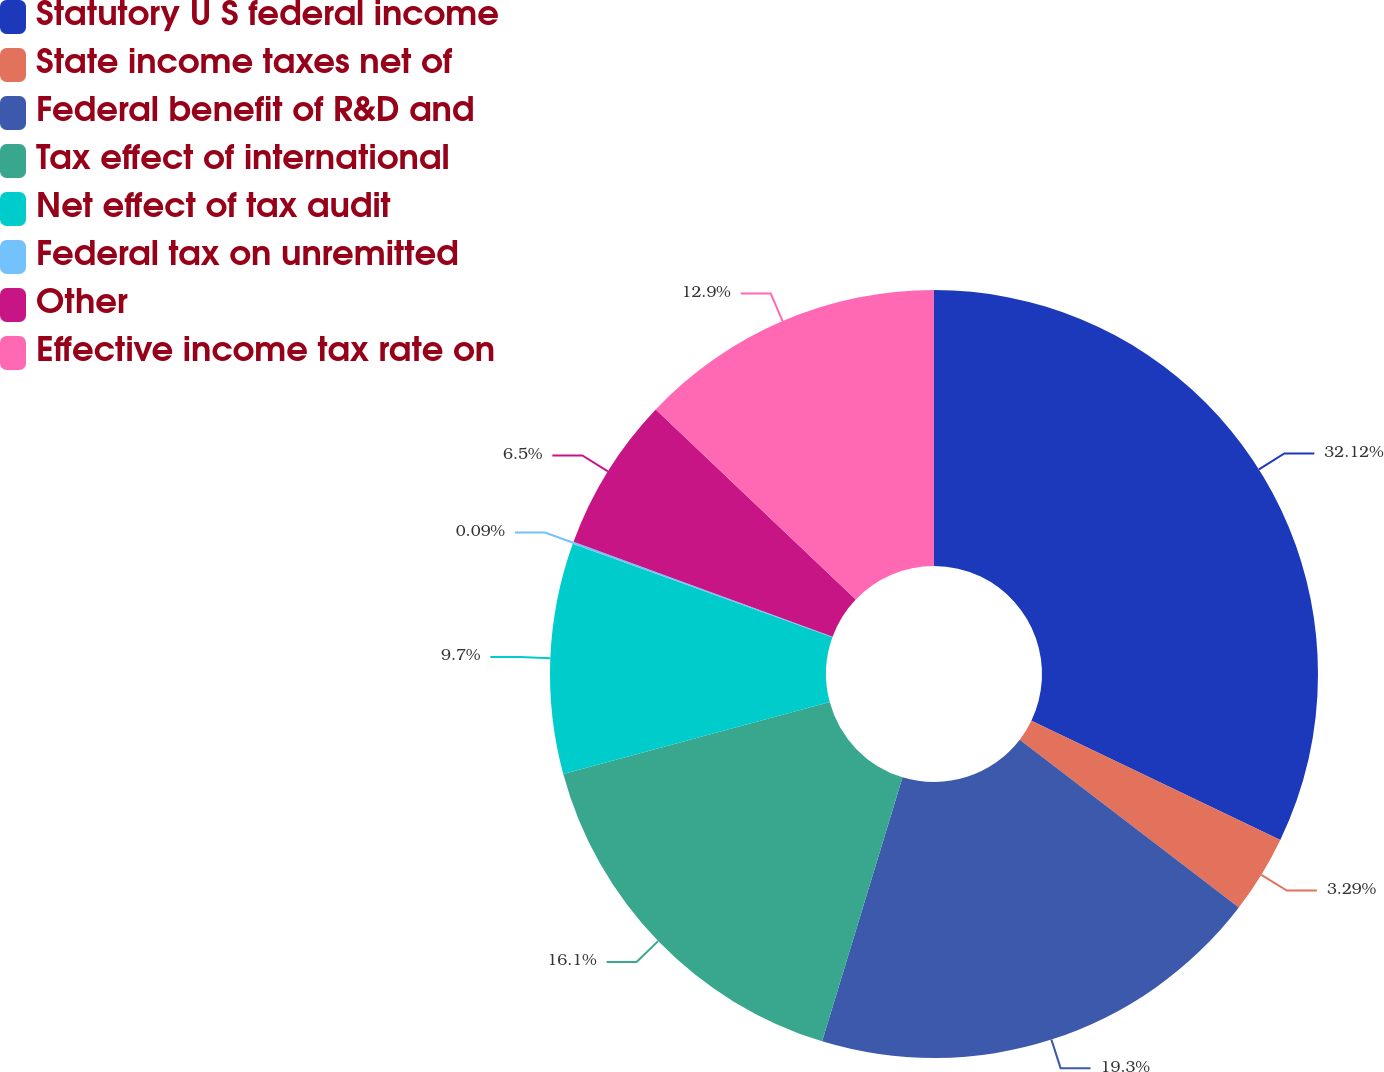Convert chart to OTSL. <chart><loc_0><loc_0><loc_500><loc_500><pie_chart><fcel>Statutory U S federal income<fcel>State income taxes net of<fcel>Federal benefit of R&D and<fcel>Tax effect of international<fcel>Net effect of tax audit<fcel>Federal tax on unremitted<fcel>Other<fcel>Effective income tax rate on<nl><fcel>32.11%<fcel>3.29%<fcel>19.3%<fcel>16.1%<fcel>9.7%<fcel>0.09%<fcel>6.5%<fcel>12.9%<nl></chart> 